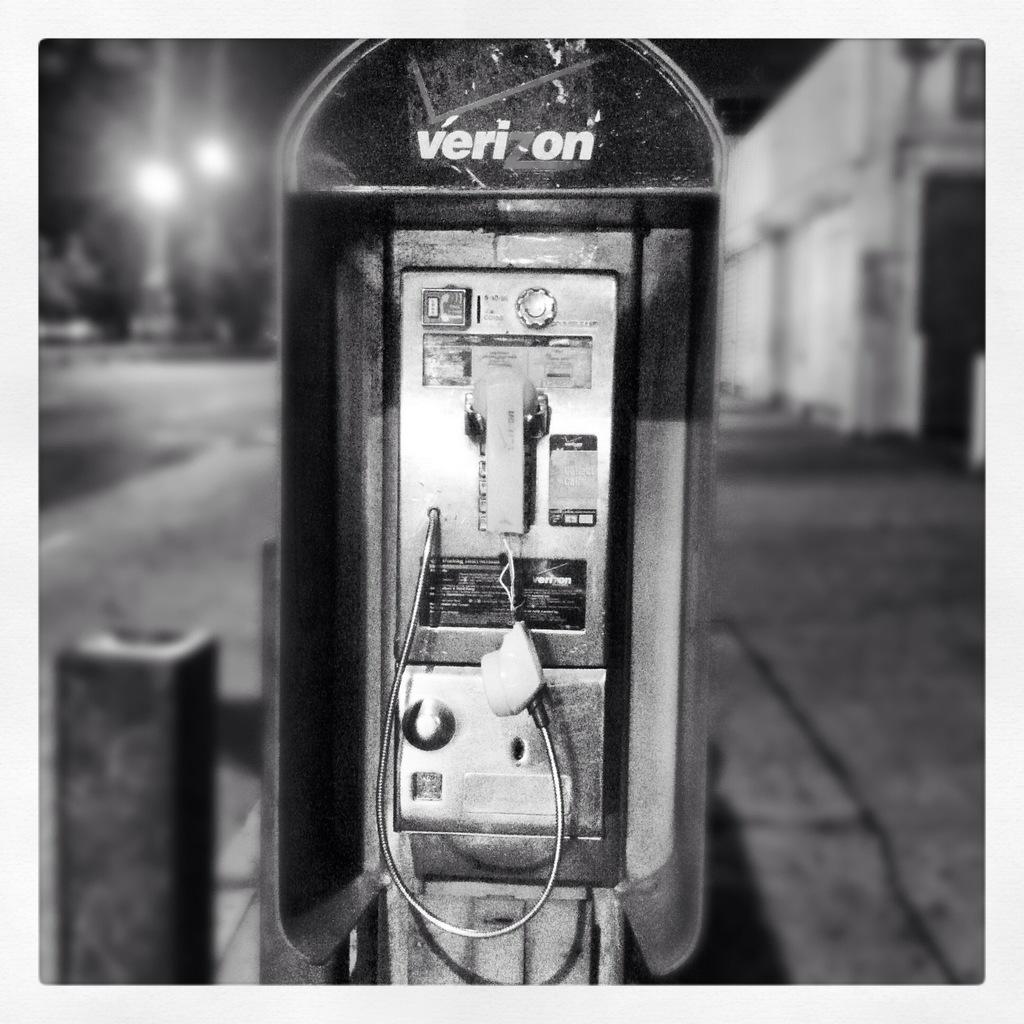What large brand is shown on the pay phone?
Your response must be concise. Verizon. 